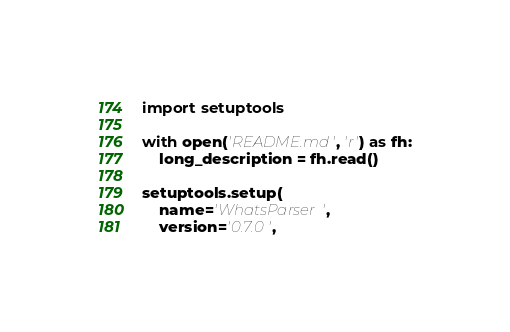<code> <loc_0><loc_0><loc_500><loc_500><_Python_>import setuptools

with open('README.md', 'r') as fh:
    long_description = fh.read()

setuptools.setup(
    name='WhatsParser',
    version='0.7.0',</code> 